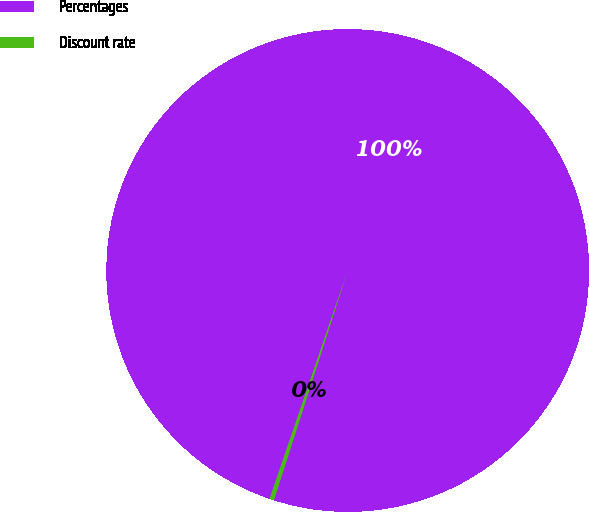<chart> <loc_0><loc_0><loc_500><loc_500><pie_chart><fcel>Percentages<fcel>Discount rate<nl><fcel>99.7%<fcel>0.3%<nl></chart> 